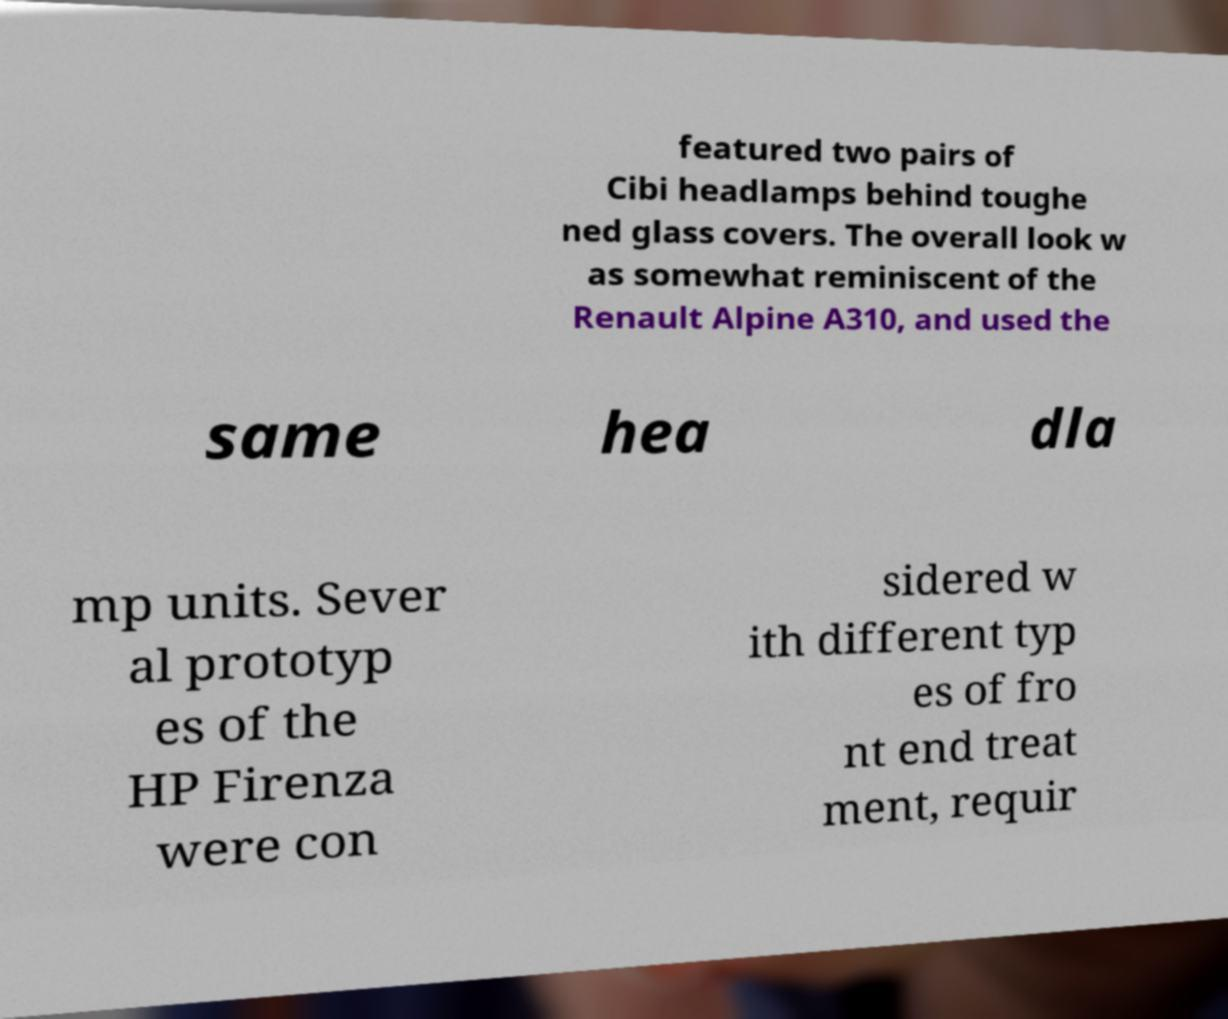Please identify and transcribe the text found in this image. featured two pairs of Cibi headlamps behind toughe ned glass covers. The overall look w as somewhat reminiscent of the Renault Alpine A310, and used the same hea dla mp units. Sever al prototyp es of the HP Firenza were con sidered w ith different typ es of fro nt end treat ment, requir 